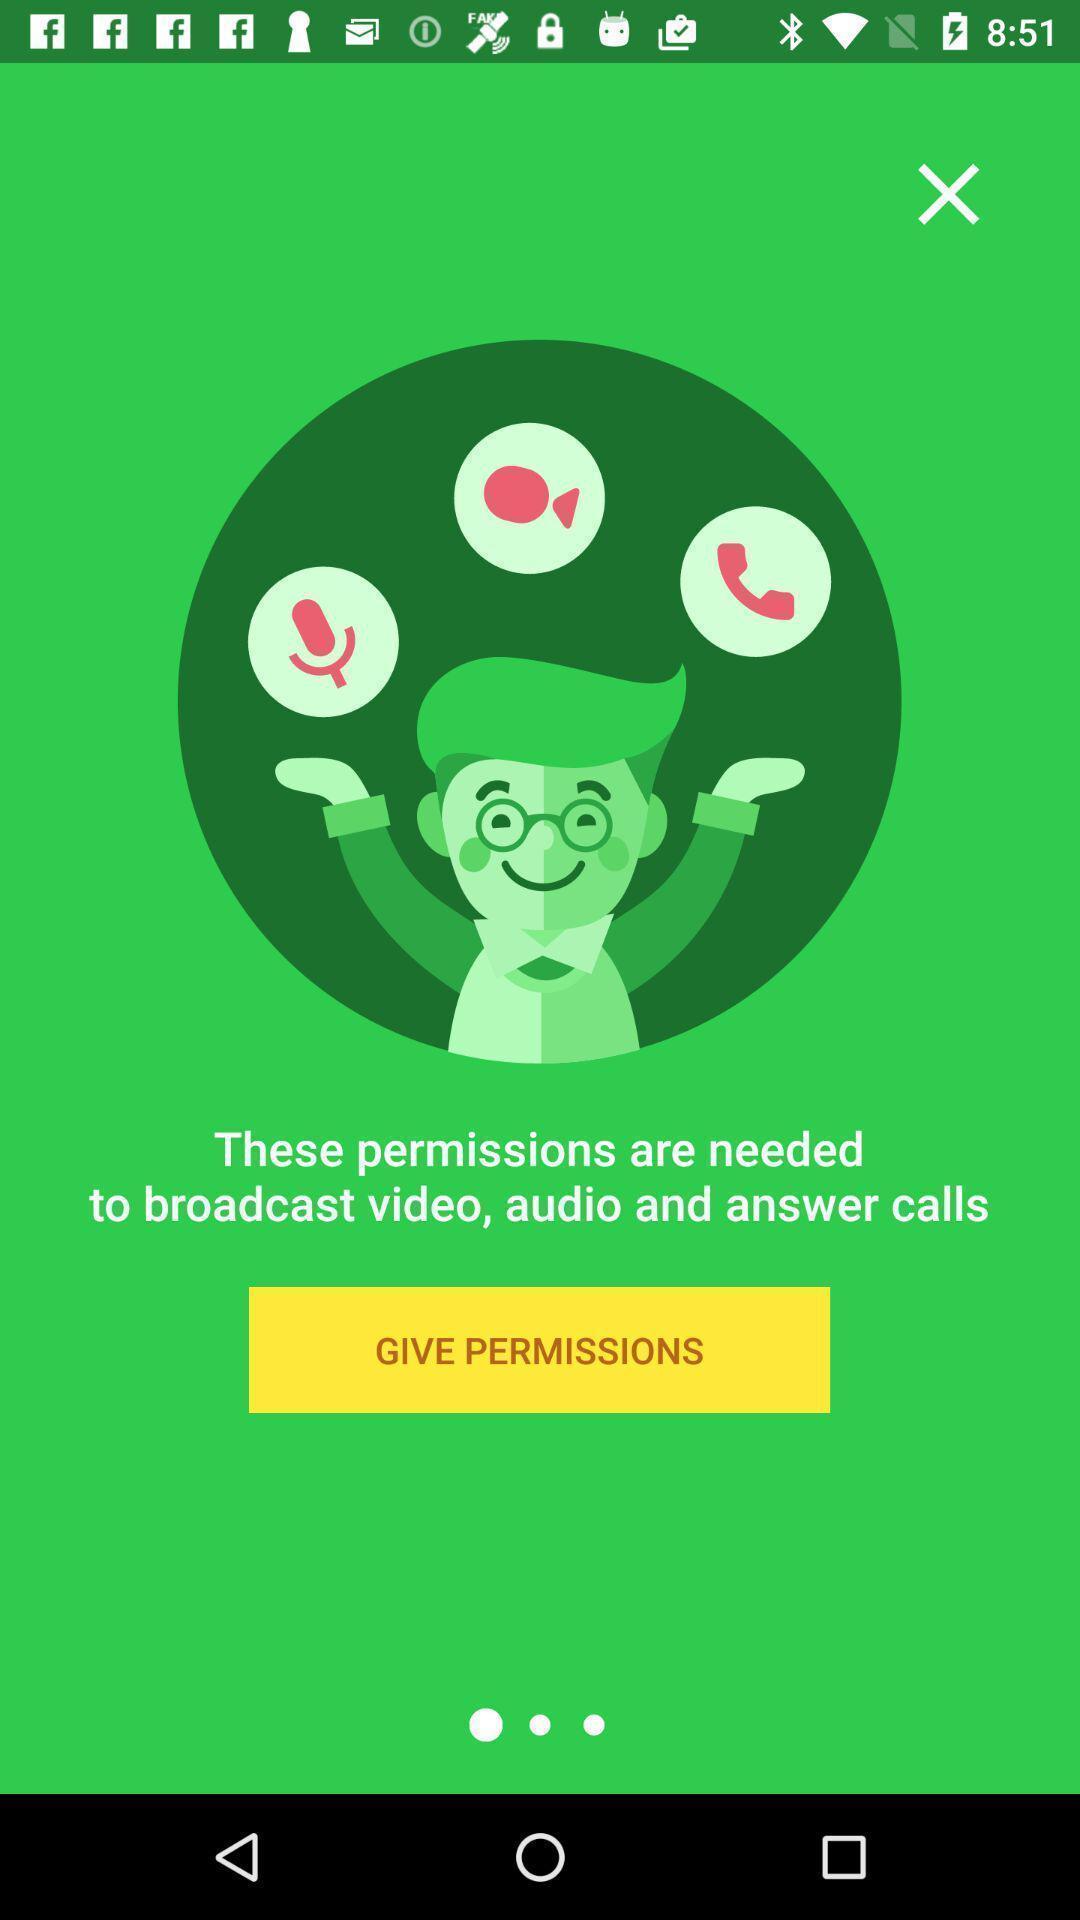Explain what's happening in this screen capture. Screen asking to give permissions to broadcast a video. 